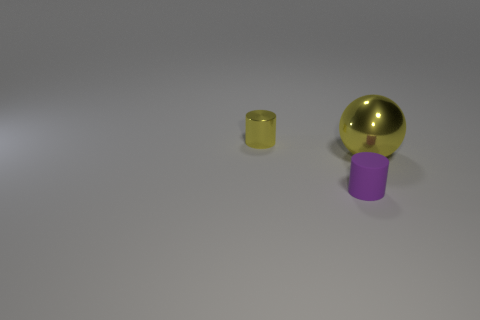There is a big yellow sphere; what number of small yellow cylinders are behind it?
Ensure brevity in your answer.  1. What material is the cylinder that is to the right of the cylinder that is behind the tiny purple cylinder made of?
Make the answer very short. Rubber. Is there anything else that is the same size as the sphere?
Your response must be concise. No. Do the purple object and the yellow cylinder have the same size?
Your response must be concise. Yes. What number of things are cylinders in front of the tiny yellow metal thing or shiny objects that are to the left of the big yellow thing?
Ensure brevity in your answer.  2. Are there more yellow objects that are on the left side of the metallic sphere than purple objects?
Offer a terse response. No. How many other objects are the same shape as the matte object?
Your answer should be compact. 1. What is the material of the thing that is both in front of the yellow cylinder and on the left side of the yellow metal sphere?
Your response must be concise. Rubber. What number of objects are cyan objects or tiny purple rubber things?
Give a very brief answer. 1. Are there more large shiny things than small green cylinders?
Keep it short and to the point. Yes. 